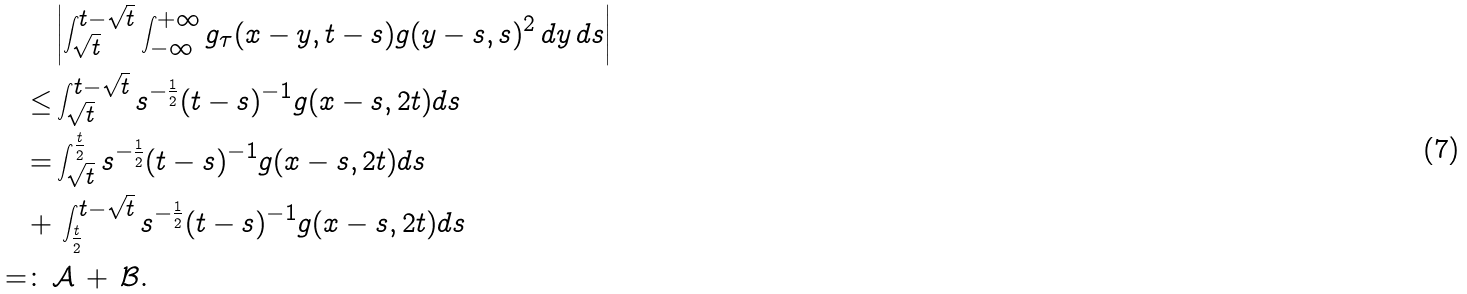Convert formula to latex. <formula><loc_0><loc_0><loc_500><loc_500>& \left | \int _ { \sqrt { t } } ^ { t - \sqrt { t } } \int _ { - \infty } ^ { + \infty } g _ { \tau } ( x - y , t - s ) g ( y - s , s ) ^ { 2 } \, d y \, d s \right | \\ \leq & \int _ { \sqrt { t } } ^ { t - \sqrt { t } } s ^ { - \frac { 1 } { 2 } } ( t - s ) ^ { - 1 } g ( x - s , 2 t ) d s \\ = & \int _ { \sqrt { t } } ^ { \frac { t } { 2 } } s ^ { - \frac { 1 } { 2 } } ( t - s ) ^ { - 1 } g ( x - s , 2 t ) d s \\ + & \, \int _ { \frac { t } { 2 } } ^ { t - \sqrt { t } } s ^ { - \frac { 1 } { 2 } } ( t - s ) ^ { - 1 } g ( x - s , 2 t ) d s \\ = \colon \, & \mathcal { A } \, + \, \mathcal { B } .</formula> 